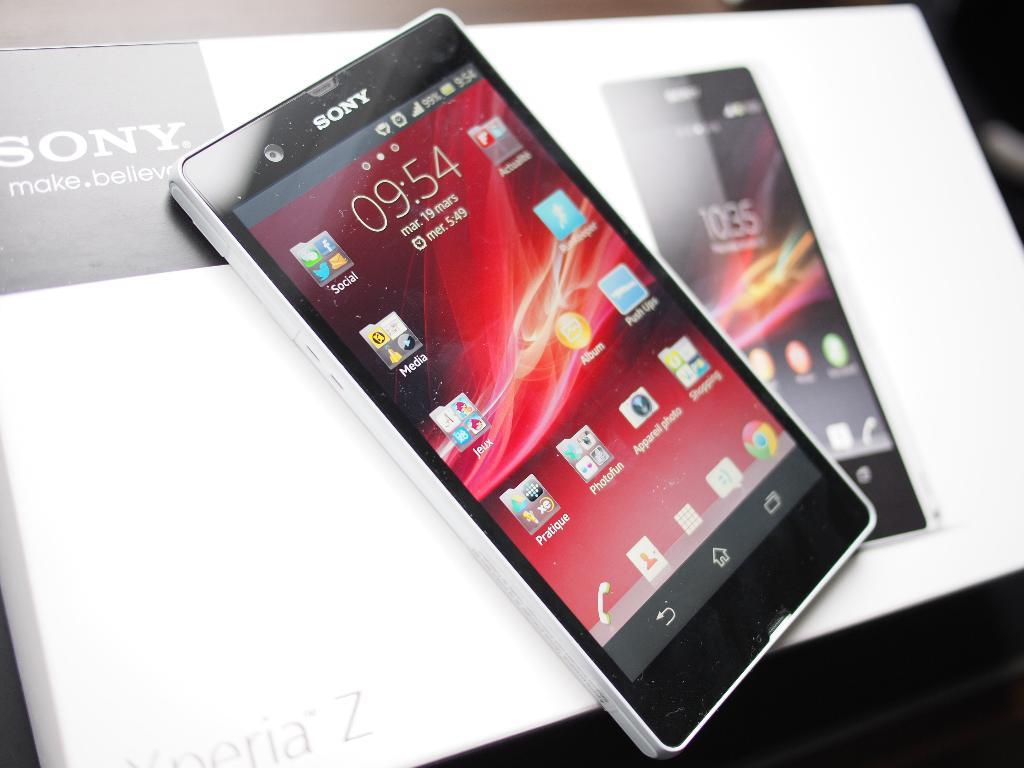<image>
Offer a succinct explanation of the picture presented. a phone with the tome of 9:54 on it 